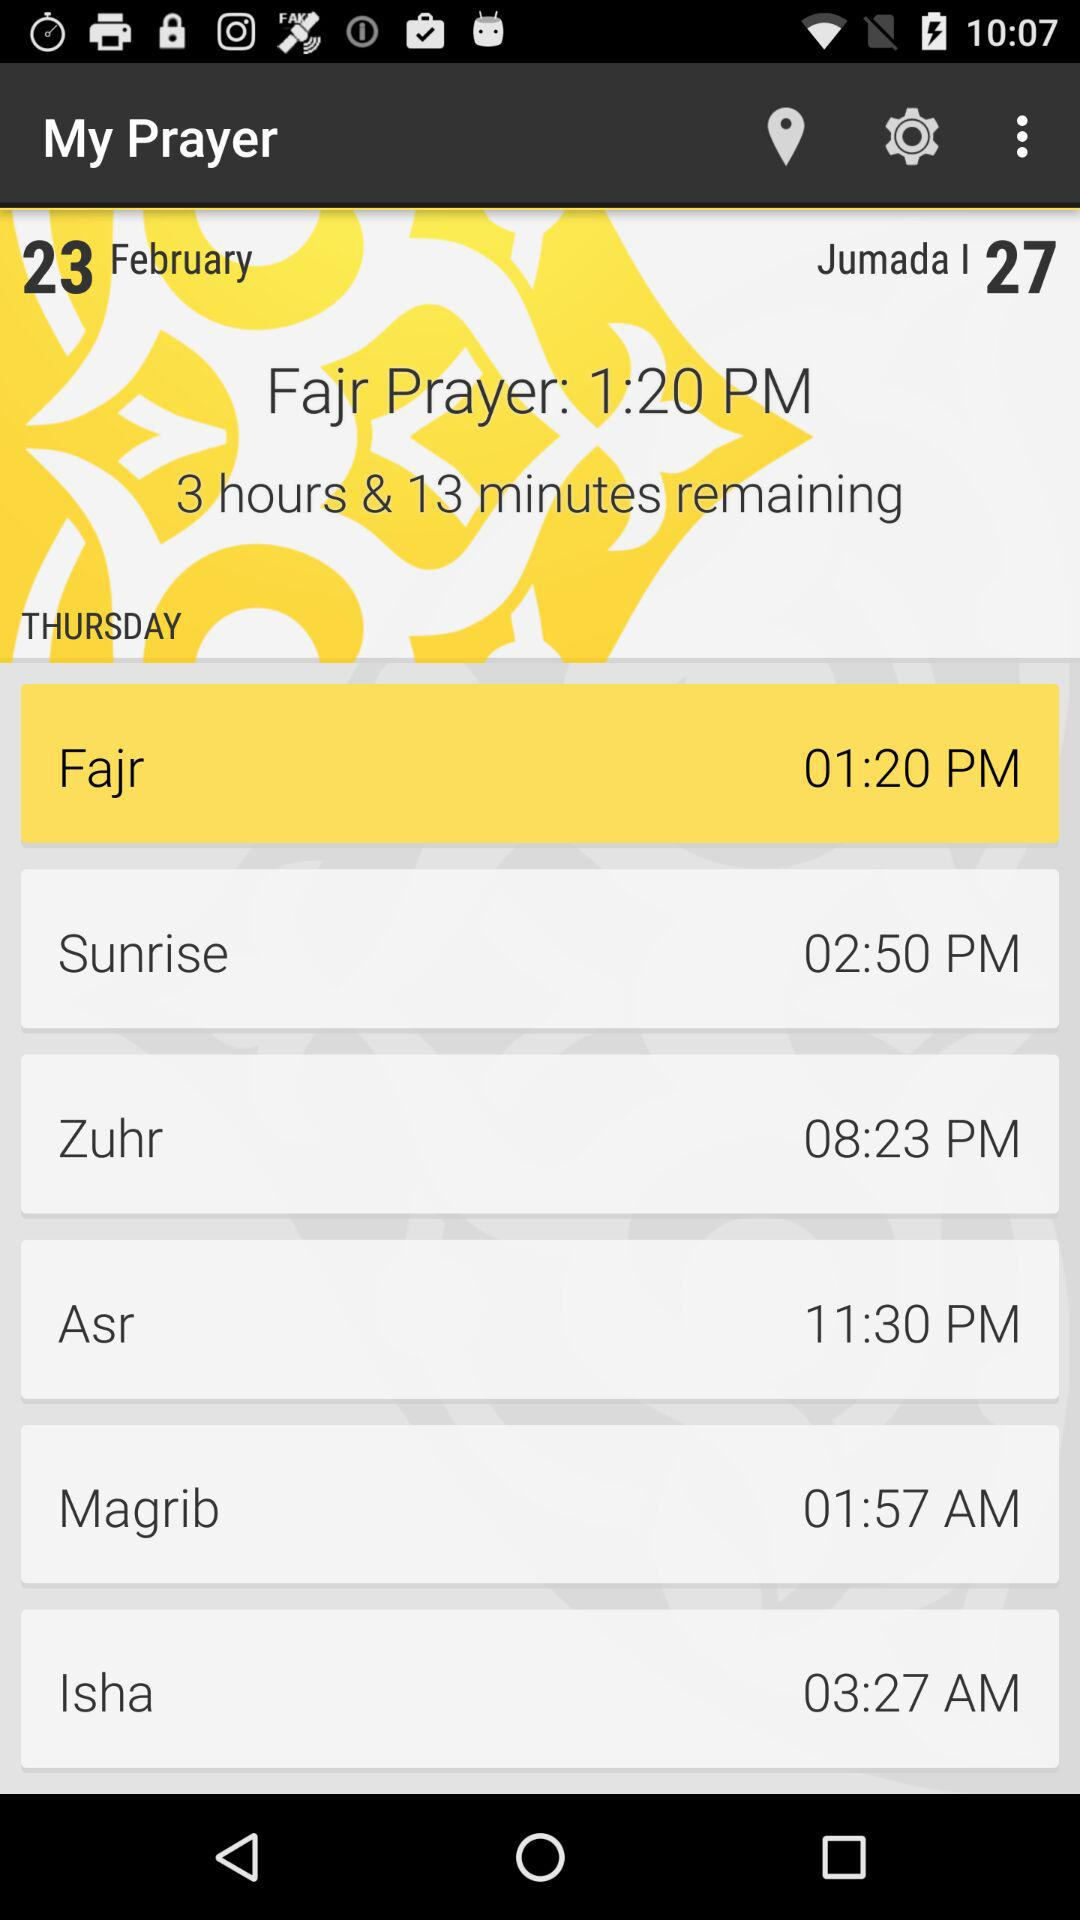What is the time of the "Fajr" prayer? The time of the "Fajr" prayer is 1:20 PM. 